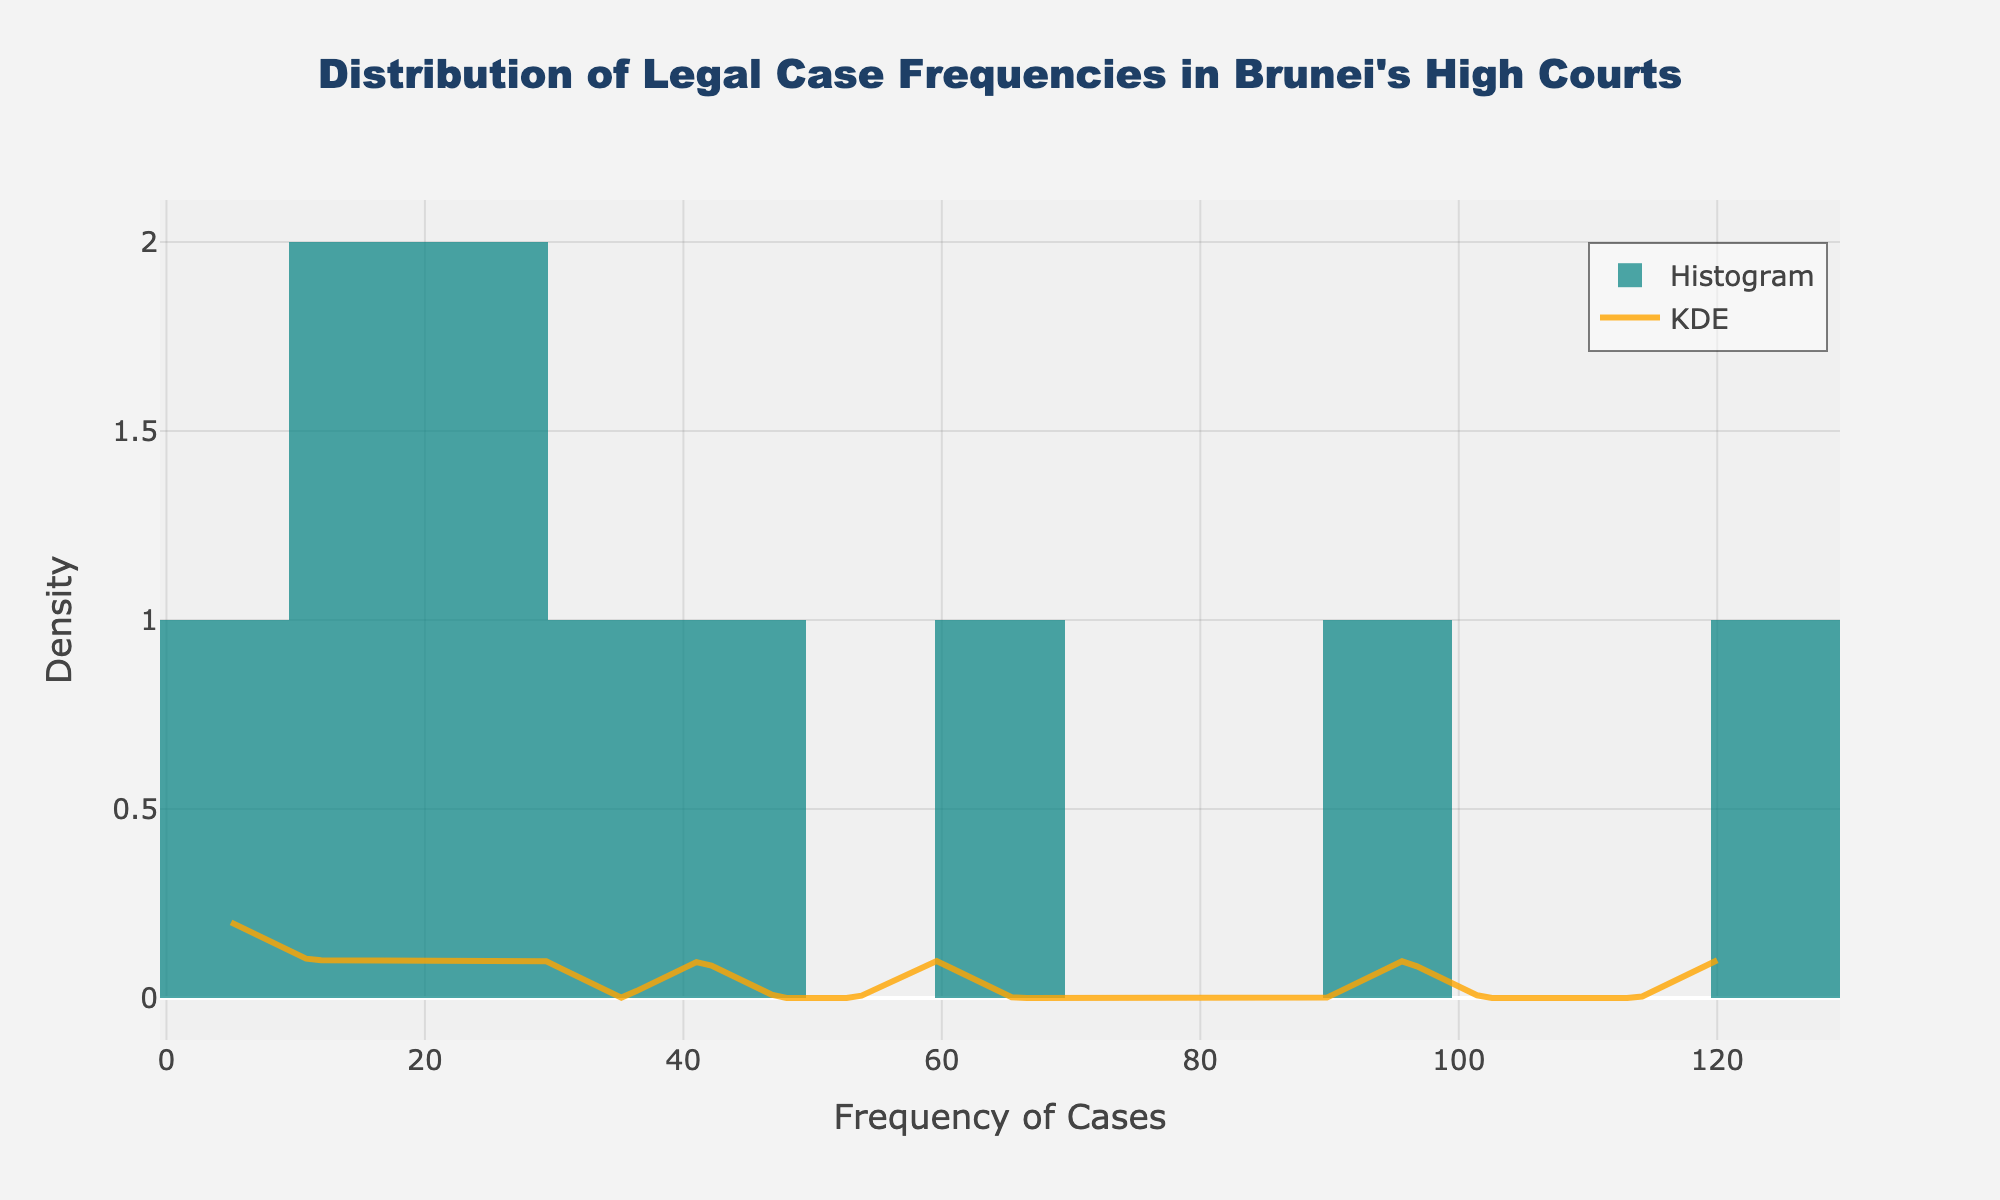Which type of legal case has the highest frequency? The "Civil" category has the highest bar, indicating the highest frequency.
Answer: Civil What is the frequency range of legal cases shown on the x-axis? The x-axis starts from 0 and ends around 130, which represents the frequency range of the legal cases.
Answer: 0 to 130 How many types of legal cases have a frequency less than 50? By examining the height and position of the bars on the histogram, we can see that Family (45), Administrative (25), Labor (30), Tax (20), Environmental (10), Intellectual Property (15), and Human Rights (5) fall below the 50 mark. There are 7 such cases.
Answer: 7 What is the most common frequency range for the legal cases, according to the histogram? The histogram indicates that the most common frequency range is between 75 and 125.
Answer: 75 to 125 Which type of legal case appears least frequently? The "Human Rights" category has the lowest height in the histogram, indicating the least frequency.
Answer: Human Rights Is there a significant difference between the highest and the second highest frequency cases? The highest is Civil with 120 and the second highest is Criminal with 95. The difference is calculated as 120 - 95 = 25.
Answer: 25 What is represented by the orange line overlaying the histogram? The orange line represents the Kernel Density Estimate (KDE), showing the distribution density of the legal cases.
Answer: KDE Which case type is closest to the median value of frequencies? The frequencies in ascending order are: 5, 10, 15, 20, 25, 30, 45, 60, 95, 120. The median falls between the 5th and 6th values (25 and 30). Hence, it's close to Labor.
Answer: Labor What's the combined frequency of Commercial and Family cases? Adding the two highest bars' frequencies: 60 (Commercial) + 45 (Family) = 105.
Answer: 105 By looking at the KDE, where does it peak and what does that tell us? The KDE peak aligns with the 120 frequency mark, indicating it's the most common single frequency among the legal cases.
Answer: 120 